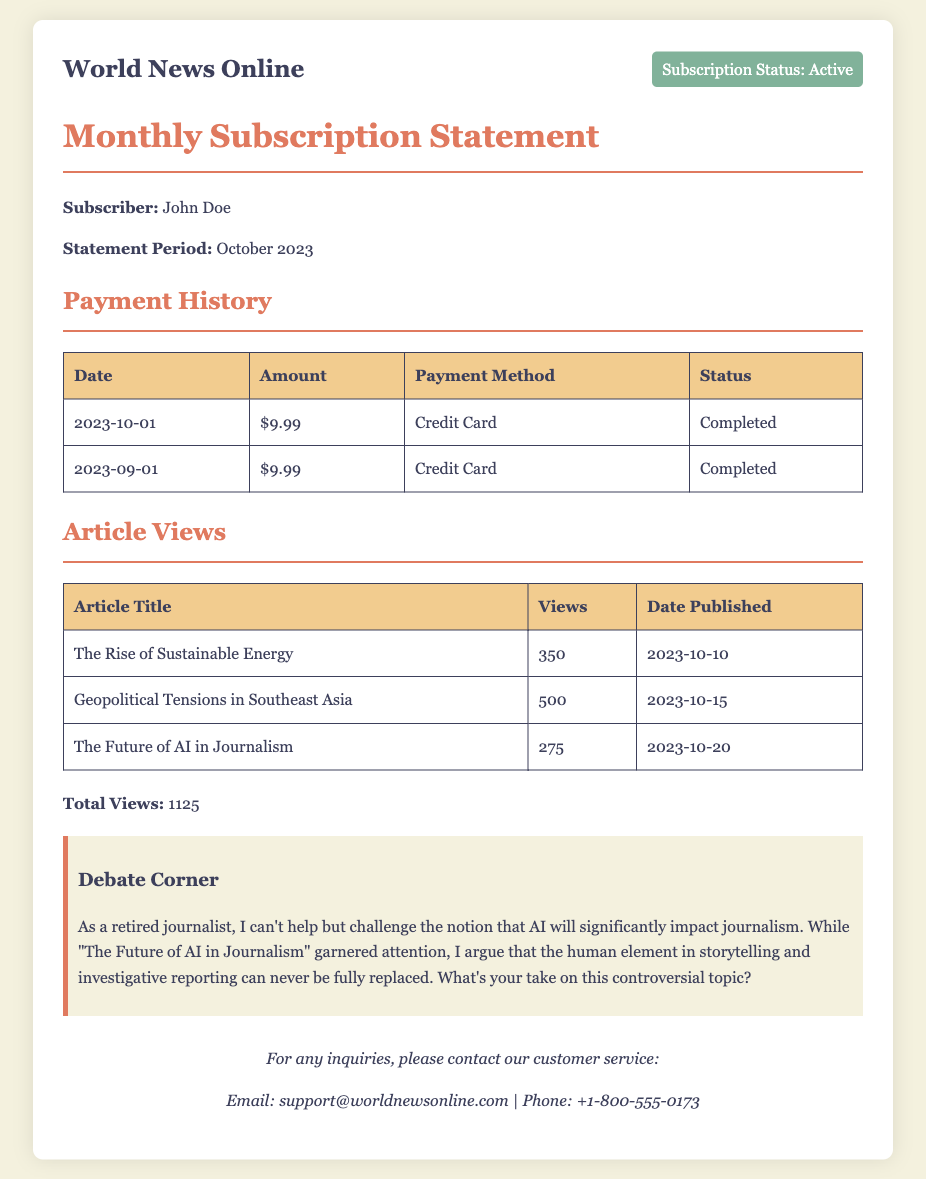What is the subscriber's name? The document states the subscriber's name as "John Doe."
Answer: John Doe What is the payment amount for October 2023? In the payment history, the amount listed for October 2023 is $9.99.
Answer: $9.99 How many articles were viewed in total? The total views summarized in the document indicate 1125 views across all articles.
Answer: 1125 What was the payment method used? The payment method listed for both transactions is "Credit Card."
Answer: Credit Card When was "Geopolitical Tensions in Southeast Asia" published? The document indicates that this article was published on "2023-10-15."
Answer: 2023-10-15 What is the subscription status? The subscription status is clearly stated in the document as "Active."
Answer: Active How many views did "The Rise of Sustainable Energy" receive? The views for this article are listed as 350 in the document.
Answer: 350 Which article had the highest number of views? The article with the highest views is "Geopolitical Tensions in Southeast Asia," with 500 views.
Answer: Geopolitical Tensions in Southeast Asia What is the email address for customer service inquiries? The document provides the customer service email as "support@worldnewsonline.com."
Answer: support@worldnewsonline.com 